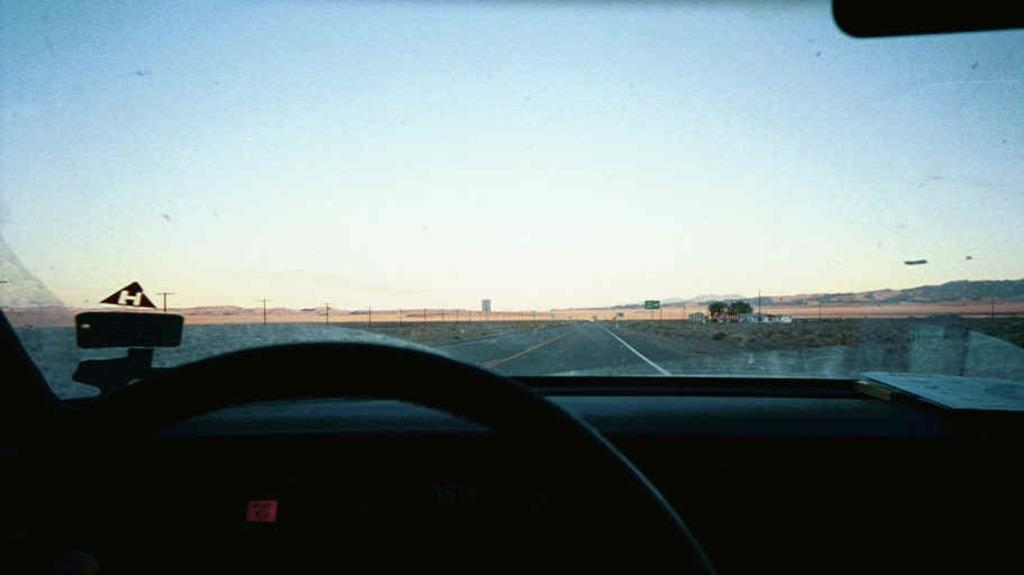What is the main subject of the image? There is a car on the road in the image. What can be seen beside the road? There are poles and a sign board beside the road. What is visible in the background of the image? There are trees, a building, and the sky visible in the background of the image. What type of bomb can be seen in the image? There is no bomb present in the image. What test is being conducted in the image? There is no test being conducted in the image. 